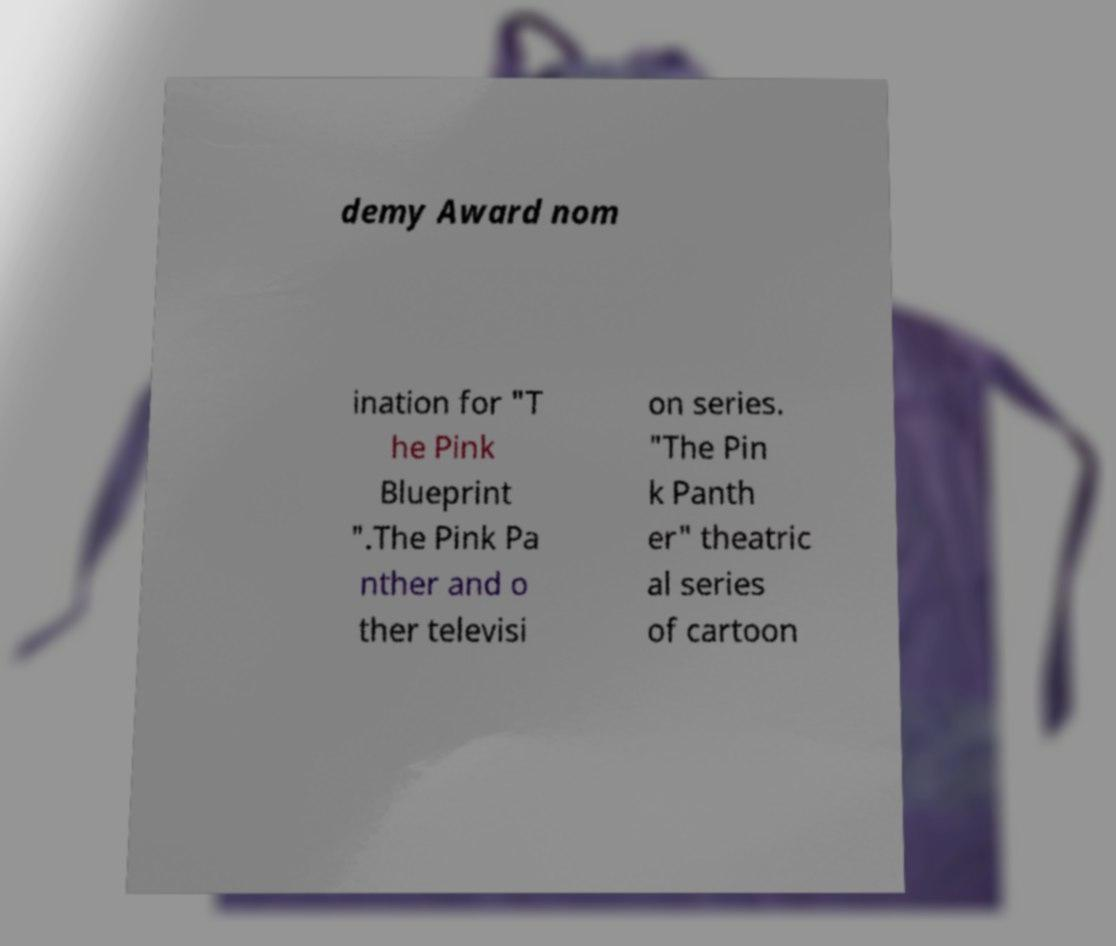Please read and relay the text visible in this image. What does it say? demy Award nom ination for "T he Pink Blueprint ".The Pink Pa nther and o ther televisi on series. "The Pin k Panth er" theatric al series of cartoon 